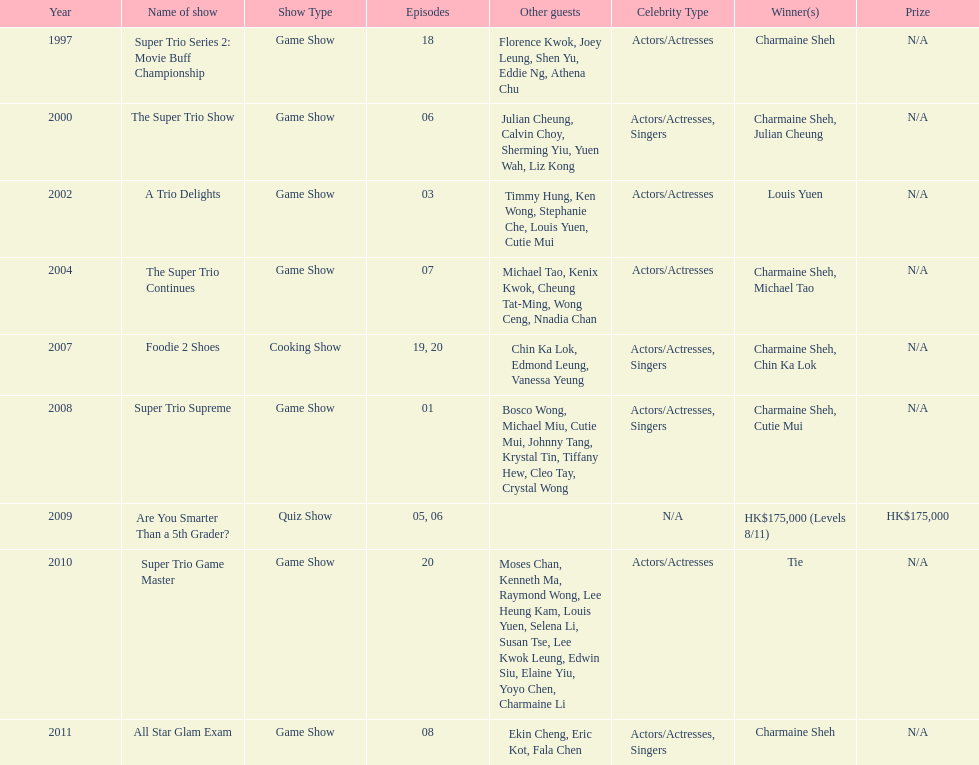How many episodes was charmaine sheh on in the variety show super trio 2: movie buff champions 18. 